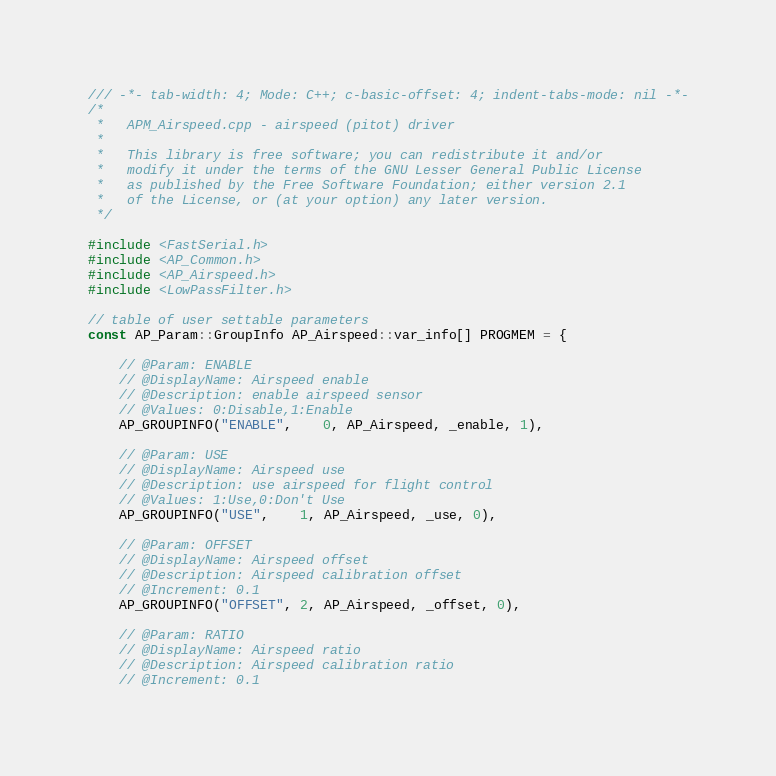<code> <loc_0><loc_0><loc_500><loc_500><_C++_>/// -*- tab-width: 4; Mode: C++; c-basic-offset: 4; indent-tabs-mode: nil -*-
/*
 *   APM_Airspeed.cpp - airspeed (pitot) driver
 *
 *   This library is free software; you can redistribute it and/or
 *   modify it under the terms of the GNU Lesser General Public License
 *   as published by the Free Software Foundation; either version 2.1
 *   of the License, or (at your option) any later version.
 */

#include <FastSerial.h>
#include <AP_Common.h>
#include <AP_Airspeed.h>
#include <LowPassFilter.h>

// table of user settable parameters
const AP_Param::GroupInfo AP_Airspeed::var_info[] PROGMEM = {

    // @Param: ENABLE
    // @DisplayName: Airspeed enable
    // @Description: enable airspeed sensor
    // @Values: 0:Disable,1:Enable
    AP_GROUPINFO("ENABLE",    0, AP_Airspeed, _enable, 1),

    // @Param: USE
    // @DisplayName: Airspeed use
    // @Description: use airspeed for flight control
    // @Values: 1:Use,0:Don't Use
    AP_GROUPINFO("USE",    1, AP_Airspeed, _use, 0),

    // @Param: OFFSET
    // @DisplayName: Airspeed offset
    // @Description: Airspeed calibration offset
    // @Increment: 0.1
    AP_GROUPINFO("OFFSET", 2, AP_Airspeed, _offset, 0),

    // @Param: RATIO
    // @DisplayName: Airspeed ratio
    // @Description: Airspeed calibration ratio
    // @Increment: 0.1</code> 